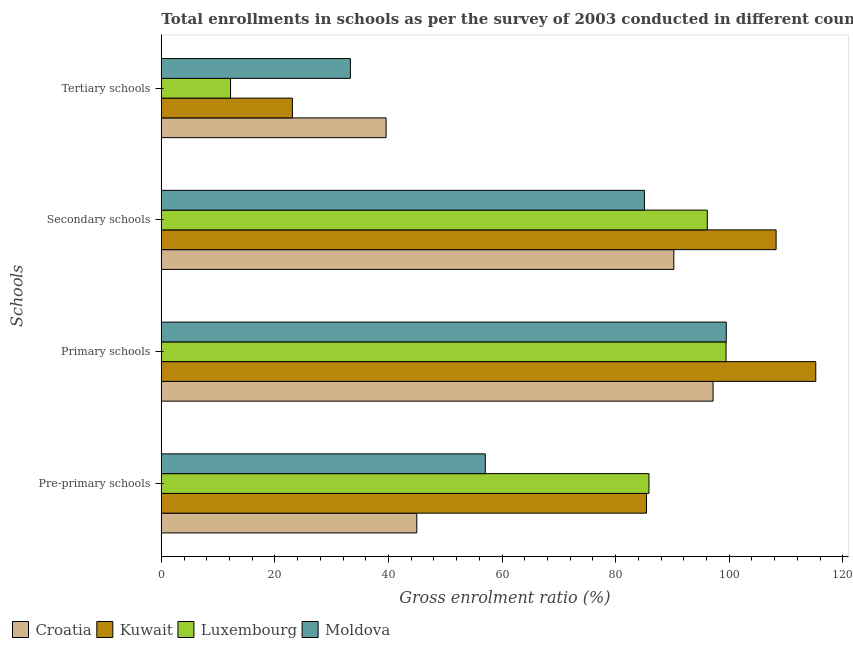How many groups of bars are there?
Your response must be concise. 4. Are the number of bars on each tick of the Y-axis equal?
Provide a short and direct response. Yes. How many bars are there on the 4th tick from the top?
Offer a terse response. 4. How many bars are there on the 4th tick from the bottom?
Provide a succinct answer. 4. What is the label of the 2nd group of bars from the top?
Make the answer very short. Secondary schools. What is the gross enrolment ratio in primary schools in Croatia?
Ensure brevity in your answer.  97.16. Across all countries, what is the maximum gross enrolment ratio in pre-primary schools?
Make the answer very short. 85.87. Across all countries, what is the minimum gross enrolment ratio in secondary schools?
Offer a very short reply. 85.07. In which country was the gross enrolment ratio in secondary schools maximum?
Your response must be concise. Kuwait. In which country was the gross enrolment ratio in pre-primary schools minimum?
Give a very brief answer. Croatia. What is the total gross enrolment ratio in pre-primary schools in the graph?
Your answer should be very brief. 273.35. What is the difference between the gross enrolment ratio in tertiary schools in Croatia and that in Moldova?
Your answer should be compact. 6.28. What is the difference between the gross enrolment ratio in primary schools in Croatia and the gross enrolment ratio in pre-primary schools in Moldova?
Offer a very short reply. 40.11. What is the average gross enrolment ratio in primary schools per country?
Your response must be concise. 102.84. What is the difference between the gross enrolment ratio in primary schools and gross enrolment ratio in tertiary schools in Moldova?
Your response must be concise. 66.19. What is the ratio of the gross enrolment ratio in pre-primary schools in Luxembourg to that in Kuwait?
Provide a short and direct response. 1.01. Is the gross enrolment ratio in pre-primary schools in Kuwait less than that in Luxembourg?
Your answer should be compact. Yes. Is the difference between the gross enrolment ratio in pre-primary schools in Luxembourg and Moldova greater than the difference between the gross enrolment ratio in secondary schools in Luxembourg and Moldova?
Your answer should be compact. Yes. What is the difference between the highest and the second highest gross enrolment ratio in primary schools?
Make the answer very short. 15.76. What is the difference between the highest and the lowest gross enrolment ratio in pre-primary schools?
Your answer should be compact. 40.89. In how many countries, is the gross enrolment ratio in pre-primary schools greater than the average gross enrolment ratio in pre-primary schools taken over all countries?
Your answer should be compact. 2. Is it the case that in every country, the sum of the gross enrolment ratio in secondary schools and gross enrolment ratio in tertiary schools is greater than the sum of gross enrolment ratio in pre-primary schools and gross enrolment ratio in primary schools?
Ensure brevity in your answer.  No. What does the 2nd bar from the top in Primary schools represents?
Your answer should be very brief. Luxembourg. What does the 2nd bar from the bottom in Secondary schools represents?
Offer a terse response. Kuwait. Is it the case that in every country, the sum of the gross enrolment ratio in pre-primary schools and gross enrolment ratio in primary schools is greater than the gross enrolment ratio in secondary schools?
Give a very brief answer. Yes. How many bars are there?
Your answer should be compact. 16. Are all the bars in the graph horizontal?
Offer a terse response. Yes. What is the difference between two consecutive major ticks on the X-axis?
Your response must be concise. 20. Are the values on the major ticks of X-axis written in scientific E-notation?
Ensure brevity in your answer.  No. How are the legend labels stacked?
Your answer should be compact. Horizontal. What is the title of the graph?
Give a very brief answer. Total enrollments in schools as per the survey of 2003 conducted in different countries. What is the label or title of the X-axis?
Keep it short and to the point. Gross enrolment ratio (%). What is the label or title of the Y-axis?
Keep it short and to the point. Schools. What is the Gross enrolment ratio (%) in Croatia in Pre-primary schools?
Keep it short and to the point. 44.99. What is the Gross enrolment ratio (%) of Kuwait in Pre-primary schools?
Provide a succinct answer. 85.44. What is the Gross enrolment ratio (%) of Luxembourg in Pre-primary schools?
Provide a succinct answer. 85.87. What is the Gross enrolment ratio (%) of Moldova in Pre-primary schools?
Your answer should be very brief. 57.05. What is the Gross enrolment ratio (%) in Croatia in Primary schools?
Ensure brevity in your answer.  97.16. What is the Gross enrolment ratio (%) of Kuwait in Primary schools?
Make the answer very short. 115.25. What is the Gross enrolment ratio (%) in Luxembourg in Primary schools?
Offer a terse response. 99.45. What is the Gross enrolment ratio (%) in Moldova in Primary schools?
Keep it short and to the point. 99.49. What is the Gross enrolment ratio (%) in Croatia in Secondary schools?
Offer a very short reply. 90.25. What is the Gross enrolment ratio (%) in Kuwait in Secondary schools?
Keep it short and to the point. 108.26. What is the Gross enrolment ratio (%) in Luxembourg in Secondary schools?
Offer a terse response. 96.14. What is the Gross enrolment ratio (%) of Moldova in Secondary schools?
Ensure brevity in your answer.  85.07. What is the Gross enrolment ratio (%) of Croatia in Tertiary schools?
Give a very brief answer. 39.58. What is the Gross enrolment ratio (%) of Kuwait in Tertiary schools?
Provide a succinct answer. 23.09. What is the Gross enrolment ratio (%) of Luxembourg in Tertiary schools?
Your response must be concise. 12.19. What is the Gross enrolment ratio (%) in Moldova in Tertiary schools?
Keep it short and to the point. 33.3. Across all Schools, what is the maximum Gross enrolment ratio (%) in Croatia?
Your answer should be very brief. 97.16. Across all Schools, what is the maximum Gross enrolment ratio (%) in Kuwait?
Your response must be concise. 115.25. Across all Schools, what is the maximum Gross enrolment ratio (%) in Luxembourg?
Offer a very short reply. 99.45. Across all Schools, what is the maximum Gross enrolment ratio (%) in Moldova?
Give a very brief answer. 99.49. Across all Schools, what is the minimum Gross enrolment ratio (%) in Croatia?
Your response must be concise. 39.58. Across all Schools, what is the minimum Gross enrolment ratio (%) in Kuwait?
Offer a terse response. 23.09. Across all Schools, what is the minimum Gross enrolment ratio (%) in Luxembourg?
Your response must be concise. 12.19. Across all Schools, what is the minimum Gross enrolment ratio (%) in Moldova?
Your answer should be very brief. 33.3. What is the total Gross enrolment ratio (%) in Croatia in the graph?
Ensure brevity in your answer.  271.98. What is the total Gross enrolment ratio (%) in Kuwait in the graph?
Offer a very short reply. 332.04. What is the total Gross enrolment ratio (%) in Luxembourg in the graph?
Give a very brief answer. 293.66. What is the total Gross enrolment ratio (%) of Moldova in the graph?
Your answer should be very brief. 274.91. What is the difference between the Gross enrolment ratio (%) of Croatia in Pre-primary schools and that in Primary schools?
Make the answer very short. -52.18. What is the difference between the Gross enrolment ratio (%) in Kuwait in Pre-primary schools and that in Primary schools?
Provide a succinct answer. -29.81. What is the difference between the Gross enrolment ratio (%) in Luxembourg in Pre-primary schools and that in Primary schools?
Provide a succinct answer. -13.57. What is the difference between the Gross enrolment ratio (%) of Moldova in Pre-primary schools and that in Primary schools?
Your response must be concise. -42.44. What is the difference between the Gross enrolment ratio (%) of Croatia in Pre-primary schools and that in Secondary schools?
Your response must be concise. -45.26. What is the difference between the Gross enrolment ratio (%) of Kuwait in Pre-primary schools and that in Secondary schools?
Your answer should be compact. -22.82. What is the difference between the Gross enrolment ratio (%) of Luxembourg in Pre-primary schools and that in Secondary schools?
Your answer should be compact. -10.27. What is the difference between the Gross enrolment ratio (%) in Moldova in Pre-primary schools and that in Secondary schools?
Offer a terse response. -28.02. What is the difference between the Gross enrolment ratio (%) in Croatia in Pre-primary schools and that in Tertiary schools?
Your answer should be very brief. 5.4. What is the difference between the Gross enrolment ratio (%) of Kuwait in Pre-primary schools and that in Tertiary schools?
Keep it short and to the point. 62.35. What is the difference between the Gross enrolment ratio (%) in Luxembourg in Pre-primary schools and that in Tertiary schools?
Give a very brief answer. 73.68. What is the difference between the Gross enrolment ratio (%) of Moldova in Pre-primary schools and that in Tertiary schools?
Your answer should be compact. 23.75. What is the difference between the Gross enrolment ratio (%) in Croatia in Primary schools and that in Secondary schools?
Your response must be concise. 6.91. What is the difference between the Gross enrolment ratio (%) of Kuwait in Primary schools and that in Secondary schools?
Keep it short and to the point. 6.99. What is the difference between the Gross enrolment ratio (%) in Luxembourg in Primary schools and that in Secondary schools?
Your answer should be very brief. 3.3. What is the difference between the Gross enrolment ratio (%) in Moldova in Primary schools and that in Secondary schools?
Give a very brief answer. 14.41. What is the difference between the Gross enrolment ratio (%) of Croatia in Primary schools and that in Tertiary schools?
Offer a terse response. 57.58. What is the difference between the Gross enrolment ratio (%) of Kuwait in Primary schools and that in Tertiary schools?
Your answer should be very brief. 92.16. What is the difference between the Gross enrolment ratio (%) in Luxembourg in Primary schools and that in Tertiary schools?
Offer a very short reply. 87.26. What is the difference between the Gross enrolment ratio (%) of Moldova in Primary schools and that in Tertiary schools?
Provide a short and direct response. 66.19. What is the difference between the Gross enrolment ratio (%) in Croatia in Secondary schools and that in Tertiary schools?
Keep it short and to the point. 50.67. What is the difference between the Gross enrolment ratio (%) in Kuwait in Secondary schools and that in Tertiary schools?
Offer a very short reply. 85.17. What is the difference between the Gross enrolment ratio (%) of Luxembourg in Secondary schools and that in Tertiary schools?
Offer a very short reply. 83.95. What is the difference between the Gross enrolment ratio (%) of Moldova in Secondary schools and that in Tertiary schools?
Provide a short and direct response. 51.77. What is the difference between the Gross enrolment ratio (%) in Croatia in Pre-primary schools and the Gross enrolment ratio (%) in Kuwait in Primary schools?
Make the answer very short. -70.26. What is the difference between the Gross enrolment ratio (%) in Croatia in Pre-primary schools and the Gross enrolment ratio (%) in Luxembourg in Primary schools?
Ensure brevity in your answer.  -54.46. What is the difference between the Gross enrolment ratio (%) of Croatia in Pre-primary schools and the Gross enrolment ratio (%) of Moldova in Primary schools?
Ensure brevity in your answer.  -54.5. What is the difference between the Gross enrolment ratio (%) of Kuwait in Pre-primary schools and the Gross enrolment ratio (%) of Luxembourg in Primary schools?
Provide a succinct answer. -14.01. What is the difference between the Gross enrolment ratio (%) in Kuwait in Pre-primary schools and the Gross enrolment ratio (%) in Moldova in Primary schools?
Provide a short and direct response. -14.05. What is the difference between the Gross enrolment ratio (%) of Luxembourg in Pre-primary schools and the Gross enrolment ratio (%) of Moldova in Primary schools?
Ensure brevity in your answer.  -13.61. What is the difference between the Gross enrolment ratio (%) in Croatia in Pre-primary schools and the Gross enrolment ratio (%) in Kuwait in Secondary schools?
Offer a very short reply. -63.28. What is the difference between the Gross enrolment ratio (%) in Croatia in Pre-primary schools and the Gross enrolment ratio (%) in Luxembourg in Secondary schools?
Provide a succinct answer. -51.16. What is the difference between the Gross enrolment ratio (%) in Croatia in Pre-primary schools and the Gross enrolment ratio (%) in Moldova in Secondary schools?
Keep it short and to the point. -40.09. What is the difference between the Gross enrolment ratio (%) in Kuwait in Pre-primary schools and the Gross enrolment ratio (%) in Luxembourg in Secondary schools?
Give a very brief answer. -10.7. What is the difference between the Gross enrolment ratio (%) of Kuwait in Pre-primary schools and the Gross enrolment ratio (%) of Moldova in Secondary schools?
Ensure brevity in your answer.  0.37. What is the difference between the Gross enrolment ratio (%) in Luxembourg in Pre-primary schools and the Gross enrolment ratio (%) in Moldova in Secondary schools?
Your response must be concise. 0.8. What is the difference between the Gross enrolment ratio (%) in Croatia in Pre-primary schools and the Gross enrolment ratio (%) in Kuwait in Tertiary schools?
Give a very brief answer. 21.9. What is the difference between the Gross enrolment ratio (%) of Croatia in Pre-primary schools and the Gross enrolment ratio (%) of Luxembourg in Tertiary schools?
Provide a short and direct response. 32.79. What is the difference between the Gross enrolment ratio (%) of Croatia in Pre-primary schools and the Gross enrolment ratio (%) of Moldova in Tertiary schools?
Offer a very short reply. 11.69. What is the difference between the Gross enrolment ratio (%) in Kuwait in Pre-primary schools and the Gross enrolment ratio (%) in Luxembourg in Tertiary schools?
Your answer should be very brief. 73.25. What is the difference between the Gross enrolment ratio (%) in Kuwait in Pre-primary schools and the Gross enrolment ratio (%) in Moldova in Tertiary schools?
Make the answer very short. 52.14. What is the difference between the Gross enrolment ratio (%) of Luxembourg in Pre-primary schools and the Gross enrolment ratio (%) of Moldova in Tertiary schools?
Make the answer very short. 52.58. What is the difference between the Gross enrolment ratio (%) in Croatia in Primary schools and the Gross enrolment ratio (%) in Kuwait in Secondary schools?
Your answer should be compact. -11.1. What is the difference between the Gross enrolment ratio (%) of Croatia in Primary schools and the Gross enrolment ratio (%) of Luxembourg in Secondary schools?
Offer a very short reply. 1.02. What is the difference between the Gross enrolment ratio (%) of Croatia in Primary schools and the Gross enrolment ratio (%) of Moldova in Secondary schools?
Offer a terse response. 12.09. What is the difference between the Gross enrolment ratio (%) in Kuwait in Primary schools and the Gross enrolment ratio (%) in Luxembourg in Secondary schools?
Make the answer very short. 19.1. What is the difference between the Gross enrolment ratio (%) of Kuwait in Primary schools and the Gross enrolment ratio (%) of Moldova in Secondary schools?
Ensure brevity in your answer.  30.17. What is the difference between the Gross enrolment ratio (%) of Luxembourg in Primary schools and the Gross enrolment ratio (%) of Moldova in Secondary schools?
Provide a succinct answer. 14.38. What is the difference between the Gross enrolment ratio (%) in Croatia in Primary schools and the Gross enrolment ratio (%) in Kuwait in Tertiary schools?
Your answer should be compact. 74.07. What is the difference between the Gross enrolment ratio (%) of Croatia in Primary schools and the Gross enrolment ratio (%) of Luxembourg in Tertiary schools?
Make the answer very short. 84.97. What is the difference between the Gross enrolment ratio (%) of Croatia in Primary schools and the Gross enrolment ratio (%) of Moldova in Tertiary schools?
Your answer should be very brief. 63.86. What is the difference between the Gross enrolment ratio (%) in Kuwait in Primary schools and the Gross enrolment ratio (%) in Luxembourg in Tertiary schools?
Your answer should be very brief. 103.06. What is the difference between the Gross enrolment ratio (%) in Kuwait in Primary schools and the Gross enrolment ratio (%) in Moldova in Tertiary schools?
Your answer should be very brief. 81.95. What is the difference between the Gross enrolment ratio (%) of Luxembourg in Primary schools and the Gross enrolment ratio (%) of Moldova in Tertiary schools?
Your answer should be very brief. 66.15. What is the difference between the Gross enrolment ratio (%) of Croatia in Secondary schools and the Gross enrolment ratio (%) of Kuwait in Tertiary schools?
Your answer should be compact. 67.16. What is the difference between the Gross enrolment ratio (%) of Croatia in Secondary schools and the Gross enrolment ratio (%) of Luxembourg in Tertiary schools?
Your answer should be compact. 78.06. What is the difference between the Gross enrolment ratio (%) of Croatia in Secondary schools and the Gross enrolment ratio (%) of Moldova in Tertiary schools?
Offer a very short reply. 56.95. What is the difference between the Gross enrolment ratio (%) in Kuwait in Secondary schools and the Gross enrolment ratio (%) in Luxembourg in Tertiary schools?
Provide a succinct answer. 96.07. What is the difference between the Gross enrolment ratio (%) of Kuwait in Secondary schools and the Gross enrolment ratio (%) of Moldova in Tertiary schools?
Ensure brevity in your answer.  74.96. What is the difference between the Gross enrolment ratio (%) in Luxembourg in Secondary schools and the Gross enrolment ratio (%) in Moldova in Tertiary schools?
Your answer should be compact. 62.85. What is the average Gross enrolment ratio (%) in Croatia per Schools?
Give a very brief answer. 68. What is the average Gross enrolment ratio (%) in Kuwait per Schools?
Offer a terse response. 83.01. What is the average Gross enrolment ratio (%) in Luxembourg per Schools?
Make the answer very short. 73.41. What is the average Gross enrolment ratio (%) of Moldova per Schools?
Your answer should be compact. 68.73. What is the difference between the Gross enrolment ratio (%) of Croatia and Gross enrolment ratio (%) of Kuwait in Pre-primary schools?
Offer a very short reply. -40.46. What is the difference between the Gross enrolment ratio (%) in Croatia and Gross enrolment ratio (%) in Luxembourg in Pre-primary schools?
Keep it short and to the point. -40.89. What is the difference between the Gross enrolment ratio (%) of Croatia and Gross enrolment ratio (%) of Moldova in Pre-primary schools?
Provide a succinct answer. -12.06. What is the difference between the Gross enrolment ratio (%) in Kuwait and Gross enrolment ratio (%) in Luxembourg in Pre-primary schools?
Make the answer very short. -0.43. What is the difference between the Gross enrolment ratio (%) in Kuwait and Gross enrolment ratio (%) in Moldova in Pre-primary schools?
Your response must be concise. 28.39. What is the difference between the Gross enrolment ratio (%) in Luxembourg and Gross enrolment ratio (%) in Moldova in Pre-primary schools?
Give a very brief answer. 28.83. What is the difference between the Gross enrolment ratio (%) in Croatia and Gross enrolment ratio (%) in Kuwait in Primary schools?
Your answer should be compact. -18.09. What is the difference between the Gross enrolment ratio (%) in Croatia and Gross enrolment ratio (%) in Luxembourg in Primary schools?
Your answer should be compact. -2.29. What is the difference between the Gross enrolment ratio (%) of Croatia and Gross enrolment ratio (%) of Moldova in Primary schools?
Give a very brief answer. -2.32. What is the difference between the Gross enrolment ratio (%) in Kuwait and Gross enrolment ratio (%) in Luxembourg in Primary schools?
Your answer should be compact. 15.8. What is the difference between the Gross enrolment ratio (%) of Kuwait and Gross enrolment ratio (%) of Moldova in Primary schools?
Offer a very short reply. 15.76. What is the difference between the Gross enrolment ratio (%) of Luxembourg and Gross enrolment ratio (%) of Moldova in Primary schools?
Give a very brief answer. -0.04. What is the difference between the Gross enrolment ratio (%) in Croatia and Gross enrolment ratio (%) in Kuwait in Secondary schools?
Your answer should be compact. -18.01. What is the difference between the Gross enrolment ratio (%) of Croatia and Gross enrolment ratio (%) of Luxembourg in Secondary schools?
Make the answer very short. -5.89. What is the difference between the Gross enrolment ratio (%) in Croatia and Gross enrolment ratio (%) in Moldova in Secondary schools?
Ensure brevity in your answer.  5.18. What is the difference between the Gross enrolment ratio (%) in Kuwait and Gross enrolment ratio (%) in Luxembourg in Secondary schools?
Offer a terse response. 12.12. What is the difference between the Gross enrolment ratio (%) of Kuwait and Gross enrolment ratio (%) of Moldova in Secondary schools?
Your answer should be compact. 23.19. What is the difference between the Gross enrolment ratio (%) of Luxembourg and Gross enrolment ratio (%) of Moldova in Secondary schools?
Offer a very short reply. 11.07. What is the difference between the Gross enrolment ratio (%) in Croatia and Gross enrolment ratio (%) in Kuwait in Tertiary schools?
Offer a very short reply. 16.49. What is the difference between the Gross enrolment ratio (%) of Croatia and Gross enrolment ratio (%) of Luxembourg in Tertiary schools?
Your answer should be compact. 27.39. What is the difference between the Gross enrolment ratio (%) in Croatia and Gross enrolment ratio (%) in Moldova in Tertiary schools?
Your response must be concise. 6.28. What is the difference between the Gross enrolment ratio (%) in Kuwait and Gross enrolment ratio (%) in Luxembourg in Tertiary schools?
Give a very brief answer. 10.9. What is the difference between the Gross enrolment ratio (%) of Kuwait and Gross enrolment ratio (%) of Moldova in Tertiary schools?
Your answer should be very brief. -10.21. What is the difference between the Gross enrolment ratio (%) in Luxembourg and Gross enrolment ratio (%) in Moldova in Tertiary schools?
Ensure brevity in your answer.  -21.11. What is the ratio of the Gross enrolment ratio (%) of Croatia in Pre-primary schools to that in Primary schools?
Provide a short and direct response. 0.46. What is the ratio of the Gross enrolment ratio (%) in Kuwait in Pre-primary schools to that in Primary schools?
Ensure brevity in your answer.  0.74. What is the ratio of the Gross enrolment ratio (%) of Luxembourg in Pre-primary schools to that in Primary schools?
Offer a very short reply. 0.86. What is the ratio of the Gross enrolment ratio (%) in Moldova in Pre-primary schools to that in Primary schools?
Offer a very short reply. 0.57. What is the ratio of the Gross enrolment ratio (%) of Croatia in Pre-primary schools to that in Secondary schools?
Give a very brief answer. 0.5. What is the ratio of the Gross enrolment ratio (%) of Kuwait in Pre-primary schools to that in Secondary schools?
Your response must be concise. 0.79. What is the ratio of the Gross enrolment ratio (%) of Luxembourg in Pre-primary schools to that in Secondary schools?
Keep it short and to the point. 0.89. What is the ratio of the Gross enrolment ratio (%) in Moldova in Pre-primary schools to that in Secondary schools?
Give a very brief answer. 0.67. What is the ratio of the Gross enrolment ratio (%) of Croatia in Pre-primary schools to that in Tertiary schools?
Your response must be concise. 1.14. What is the ratio of the Gross enrolment ratio (%) of Kuwait in Pre-primary schools to that in Tertiary schools?
Ensure brevity in your answer.  3.7. What is the ratio of the Gross enrolment ratio (%) in Luxembourg in Pre-primary schools to that in Tertiary schools?
Your answer should be compact. 7.04. What is the ratio of the Gross enrolment ratio (%) of Moldova in Pre-primary schools to that in Tertiary schools?
Provide a succinct answer. 1.71. What is the ratio of the Gross enrolment ratio (%) in Croatia in Primary schools to that in Secondary schools?
Offer a very short reply. 1.08. What is the ratio of the Gross enrolment ratio (%) in Kuwait in Primary schools to that in Secondary schools?
Your answer should be compact. 1.06. What is the ratio of the Gross enrolment ratio (%) of Luxembourg in Primary schools to that in Secondary schools?
Offer a terse response. 1.03. What is the ratio of the Gross enrolment ratio (%) of Moldova in Primary schools to that in Secondary schools?
Ensure brevity in your answer.  1.17. What is the ratio of the Gross enrolment ratio (%) in Croatia in Primary schools to that in Tertiary schools?
Provide a succinct answer. 2.45. What is the ratio of the Gross enrolment ratio (%) of Kuwait in Primary schools to that in Tertiary schools?
Your answer should be compact. 4.99. What is the ratio of the Gross enrolment ratio (%) in Luxembourg in Primary schools to that in Tertiary schools?
Give a very brief answer. 8.16. What is the ratio of the Gross enrolment ratio (%) in Moldova in Primary schools to that in Tertiary schools?
Provide a short and direct response. 2.99. What is the ratio of the Gross enrolment ratio (%) in Croatia in Secondary schools to that in Tertiary schools?
Ensure brevity in your answer.  2.28. What is the ratio of the Gross enrolment ratio (%) in Kuwait in Secondary schools to that in Tertiary schools?
Give a very brief answer. 4.69. What is the ratio of the Gross enrolment ratio (%) of Luxembourg in Secondary schools to that in Tertiary schools?
Provide a succinct answer. 7.89. What is the ratio of the Gross enrolment ratio (%) in Moldova in Secondary schools to that in Tertiary schools?
Give a very brief answer. 2.55. What is the difference between the highest and the second highest Gross enrolment ratio (%) in Croatia?
Your answer should be compact. 6.91. What is the difference between the highest and the second highest Gross enrolment ratio (%) of Kuwait?
Ensure brevity in your answer.  6.99. What is the difference between the highest and the second highest Gross enrolment ratio (%) of Luxembourg?
Offer a terse response. 3.3. What is the difference between the highest and the second highest Gross enrolment ratio (%) of Moldova?
Offer a terse response. 14.41. What is the difference between the highest and the lowest Gross enrolment ratio (%) of Croatia?
Keep it short and to the point. 57.58. What is the difference between the highest and the lowest Gross enrolment ratio (%) of Kuwait?
Keep it short and to the point. 92.16. What is the difference between the highest and the lowest Gross enrolment ratio (%) in Luxembourg?
Ensure brevity in your answer.  87.26. What is the difference between the highest and the lowest Gross enrolment ratio (%) in Moldova?
Your answer should be very brief. 66.19. 